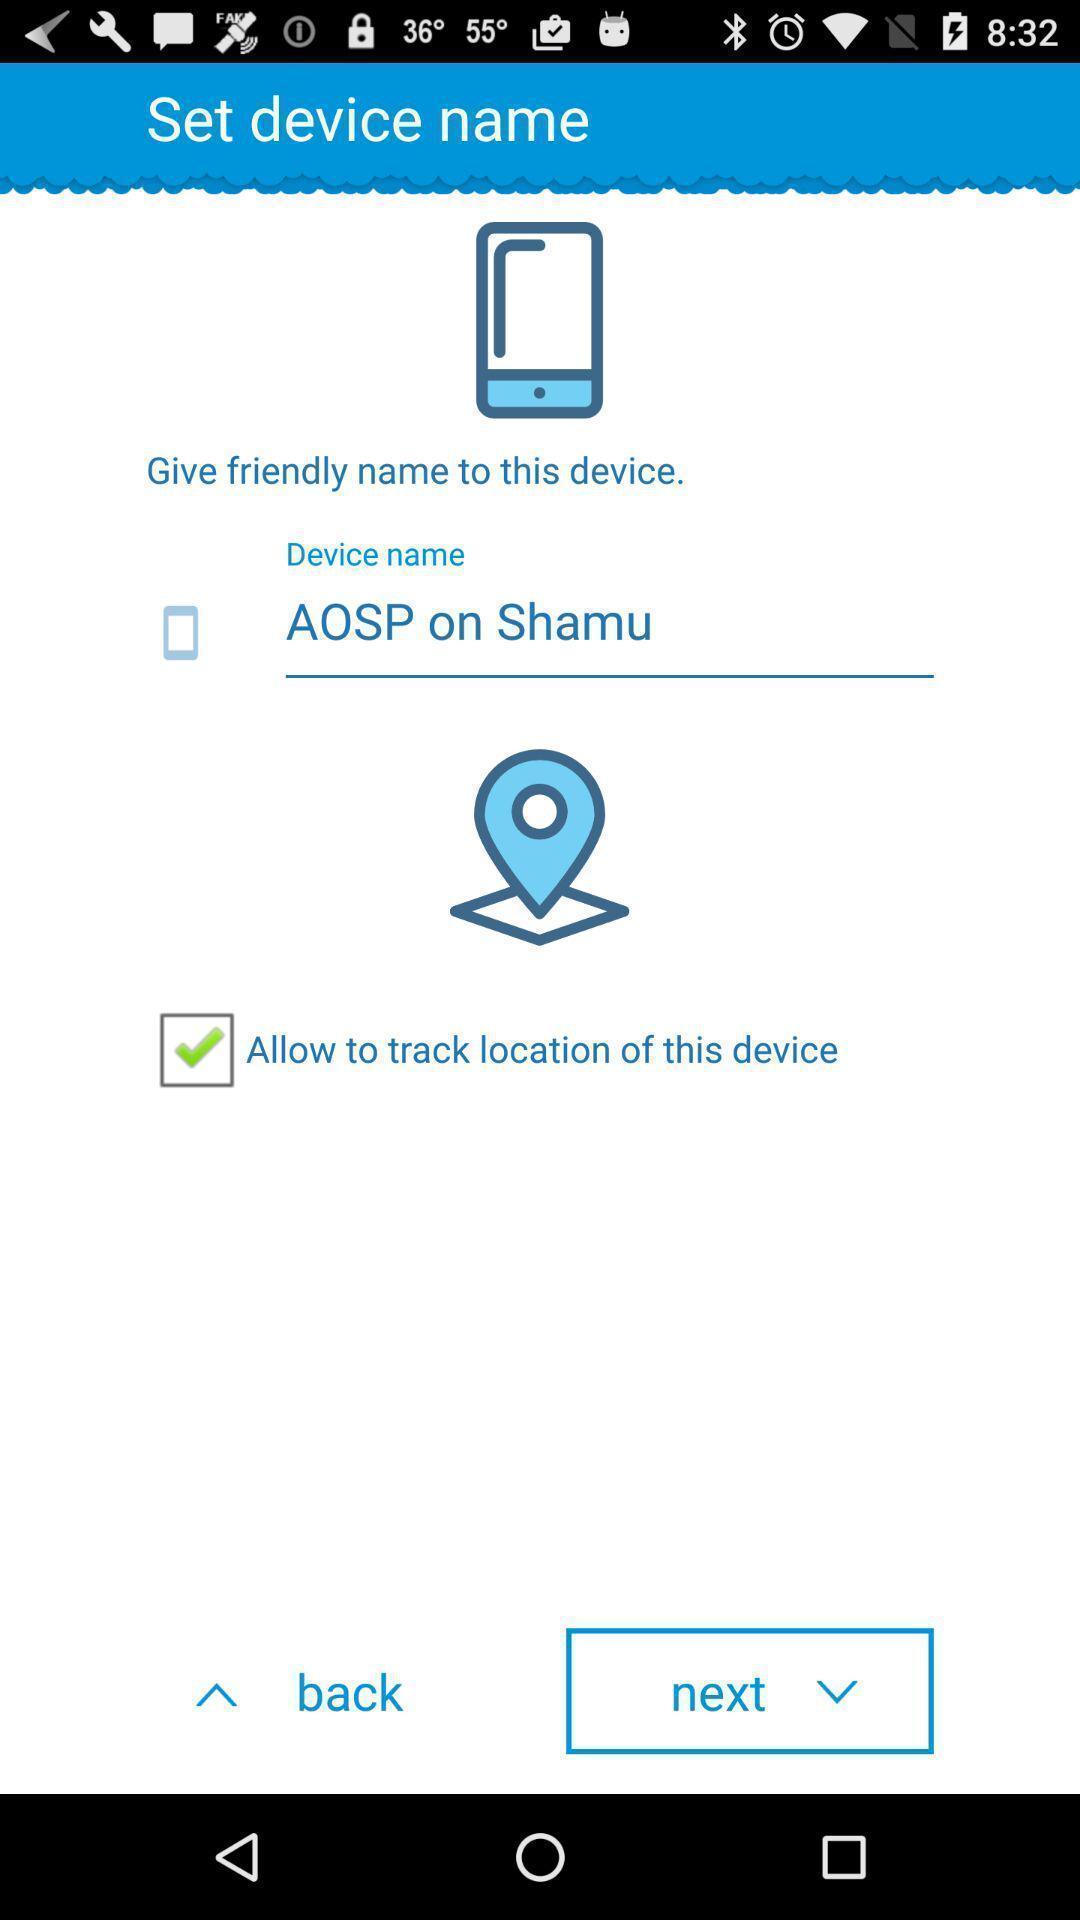What details can you identify in this image? Setting up device name for your device. 